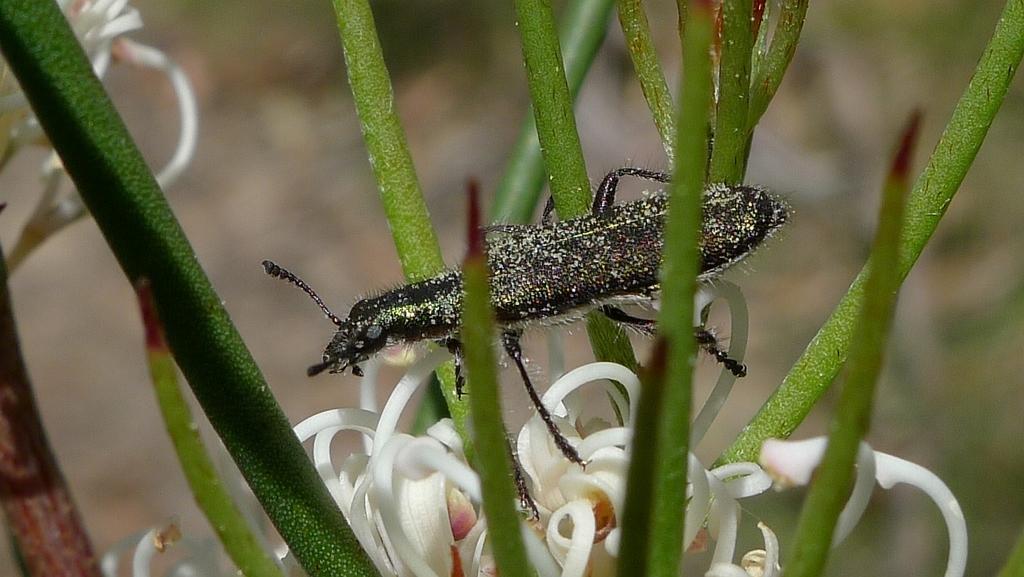In one or two sentences, can you explain what this image depicts? In this image there is an insect on a plant, in the background it is blurred. 